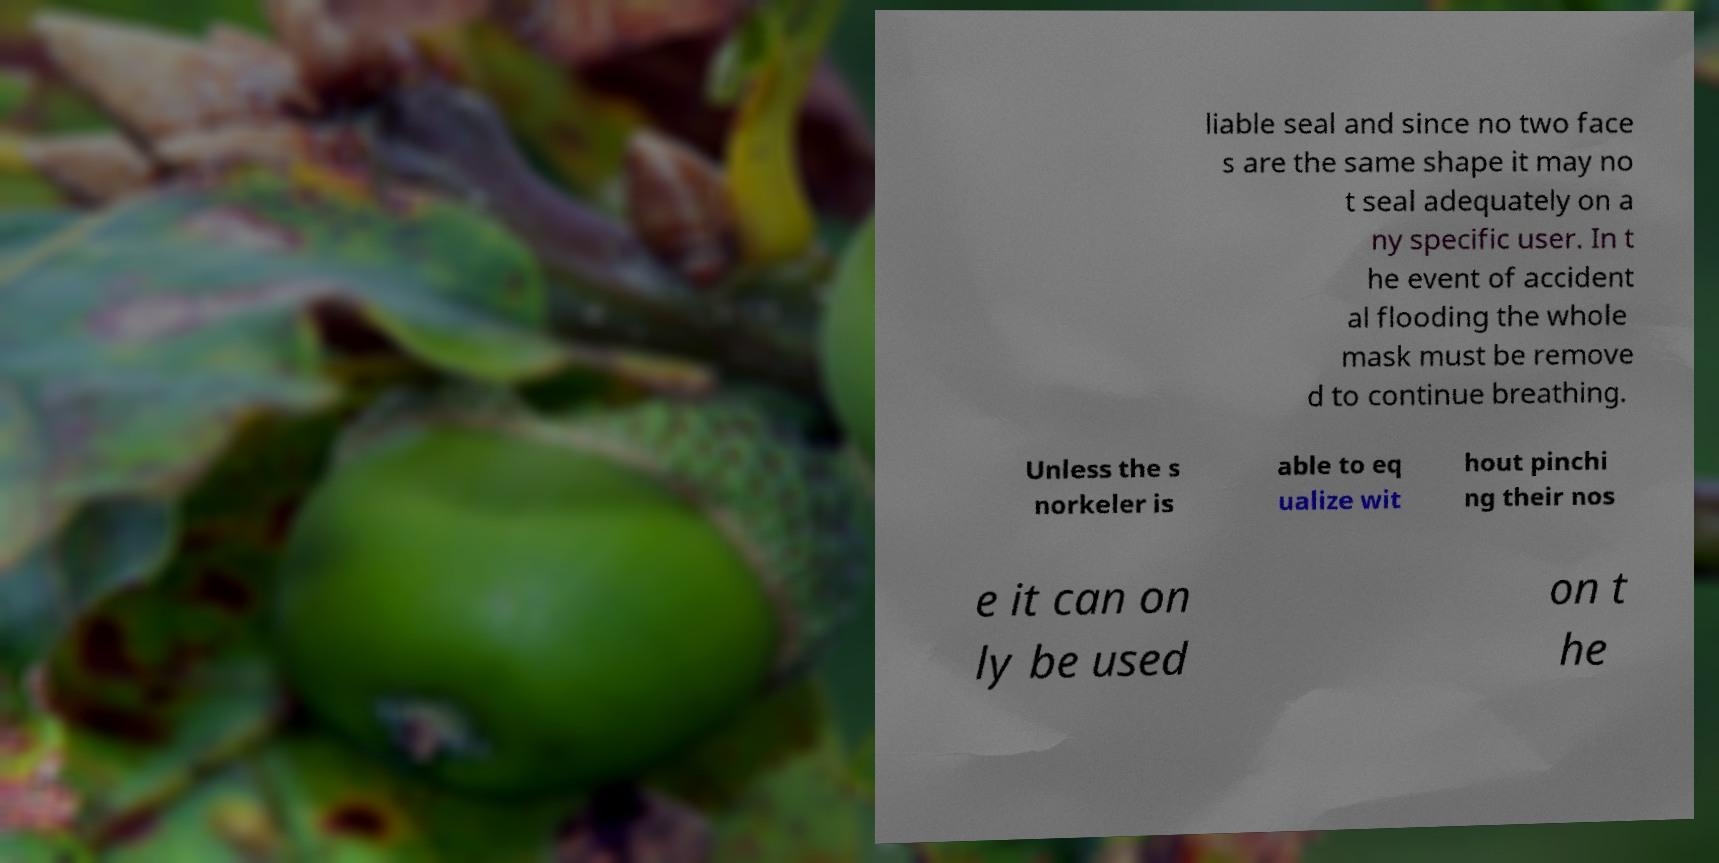Could you extract and type out the text from this image? liable seal and since no two face s are the same shape it may no t seal adequately on a ny specific user. In t he event of accident al flooding the whole mask must be remove d to continue breathing. Unless the s norkeler is able to eq ualize wit hout pinchi ng their nos e it can on ly be used on t he 